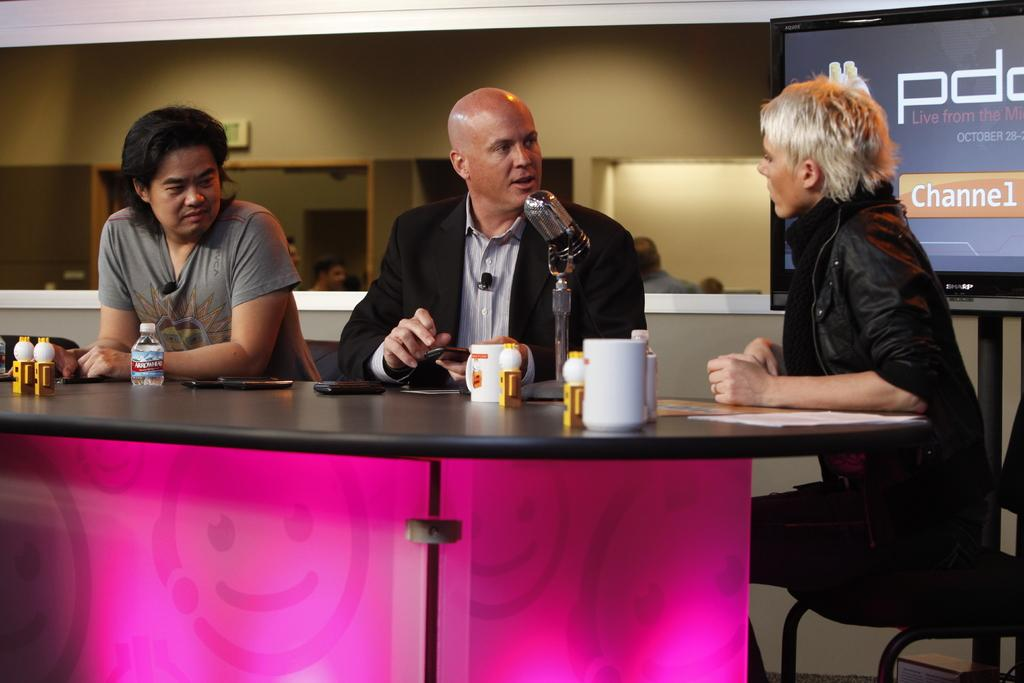What can be seen on the wall in the image? There is a banner on the wall in the image. How many people are sitting in the image? There are three people sitting on chairs in the image. What is present on the table in the image? There are cups, a bottle, and mobile phones on the table in the image. What type of joke is being told by the people in the image? There is no indication of a joke being told in the image; the people are simply sitting on chairs. Can you see any fire in the image? There is no fire present in the image. 